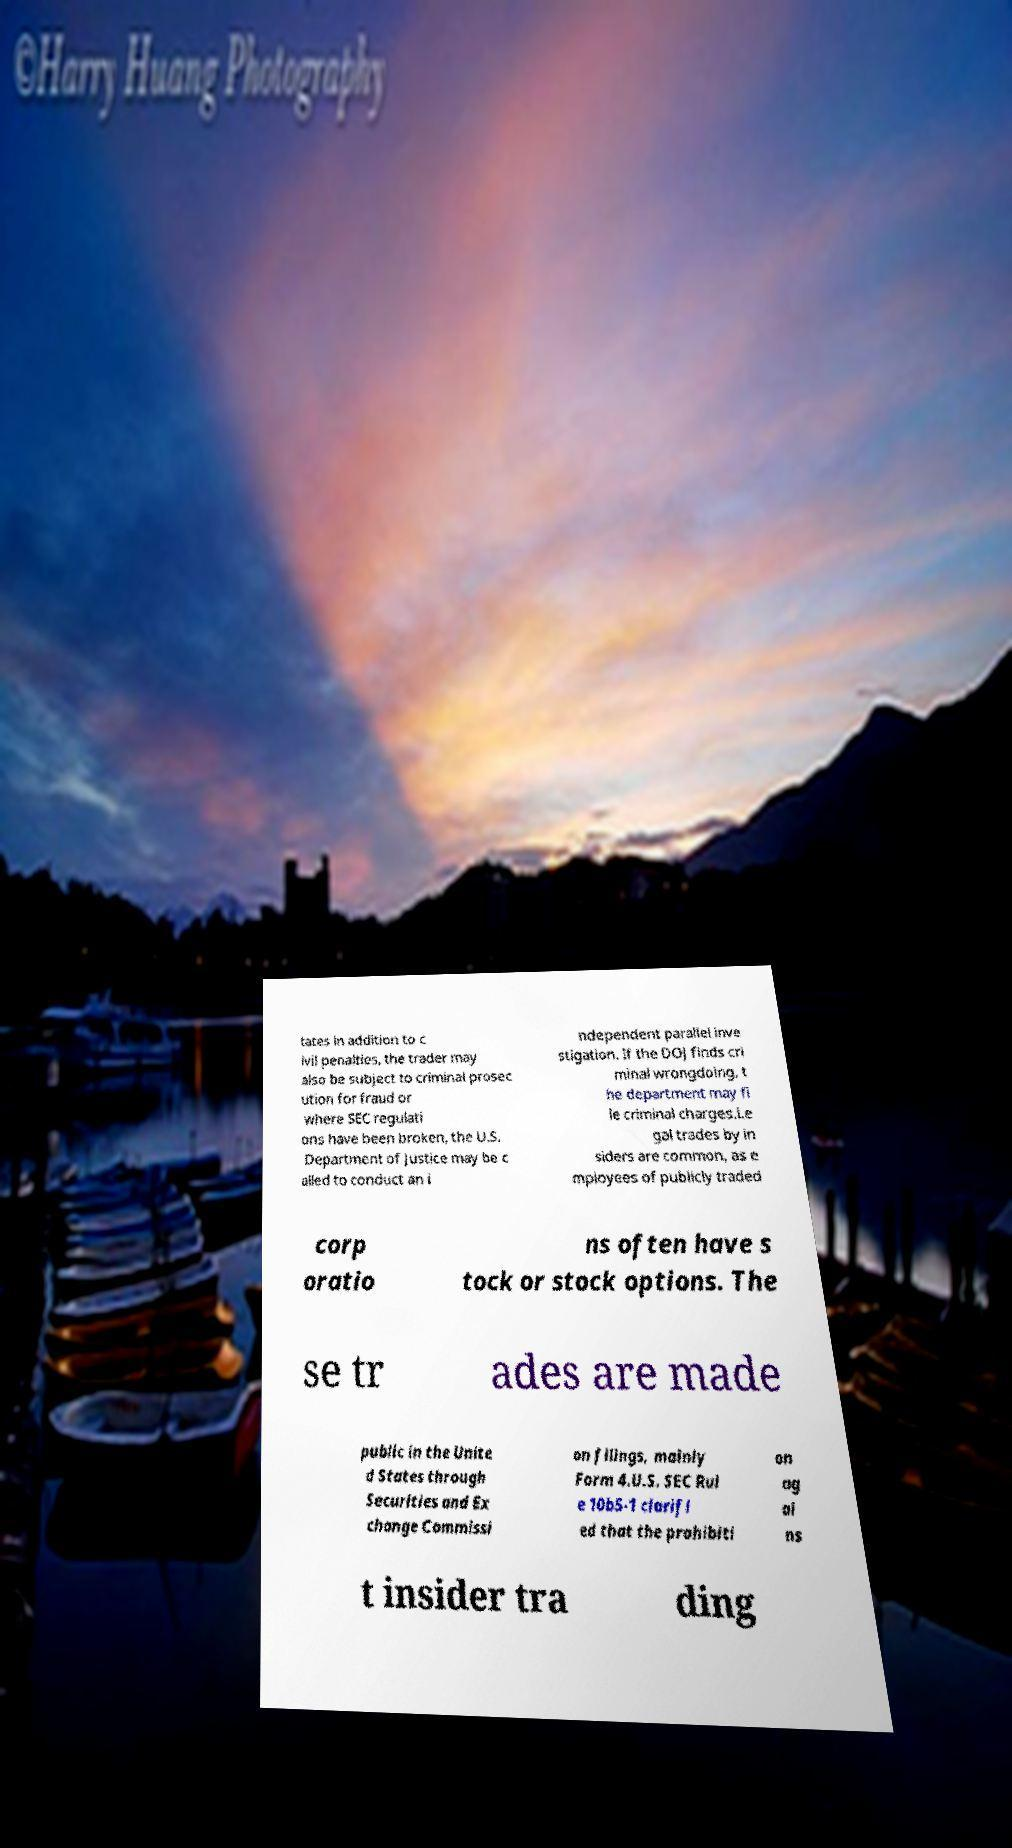Could you extract and type out the text from this image? tates in addition to c ivil penalties, the trader may also be subject to criminal prosec ution for fraud or where SEC regulati ons have been broken, the U.S. Department of Justice may be c alled to conduct an i ndependent parallel inve stigation. If the DOJ finds cri minal wrongdoing, t he department may fi le criminal charges.Le gal trades by in siders are common, as e mployees of publicly traded corp oratio ns often have s tock or stock options. The se tr ades are made public in the Unite d States through Securities and Ex change Commissi on filings, mainly Form 4.U.S. SEC Rul e 10b5-1 clarifi ed that the prohibiti on ag ai ns t insider tra ding 